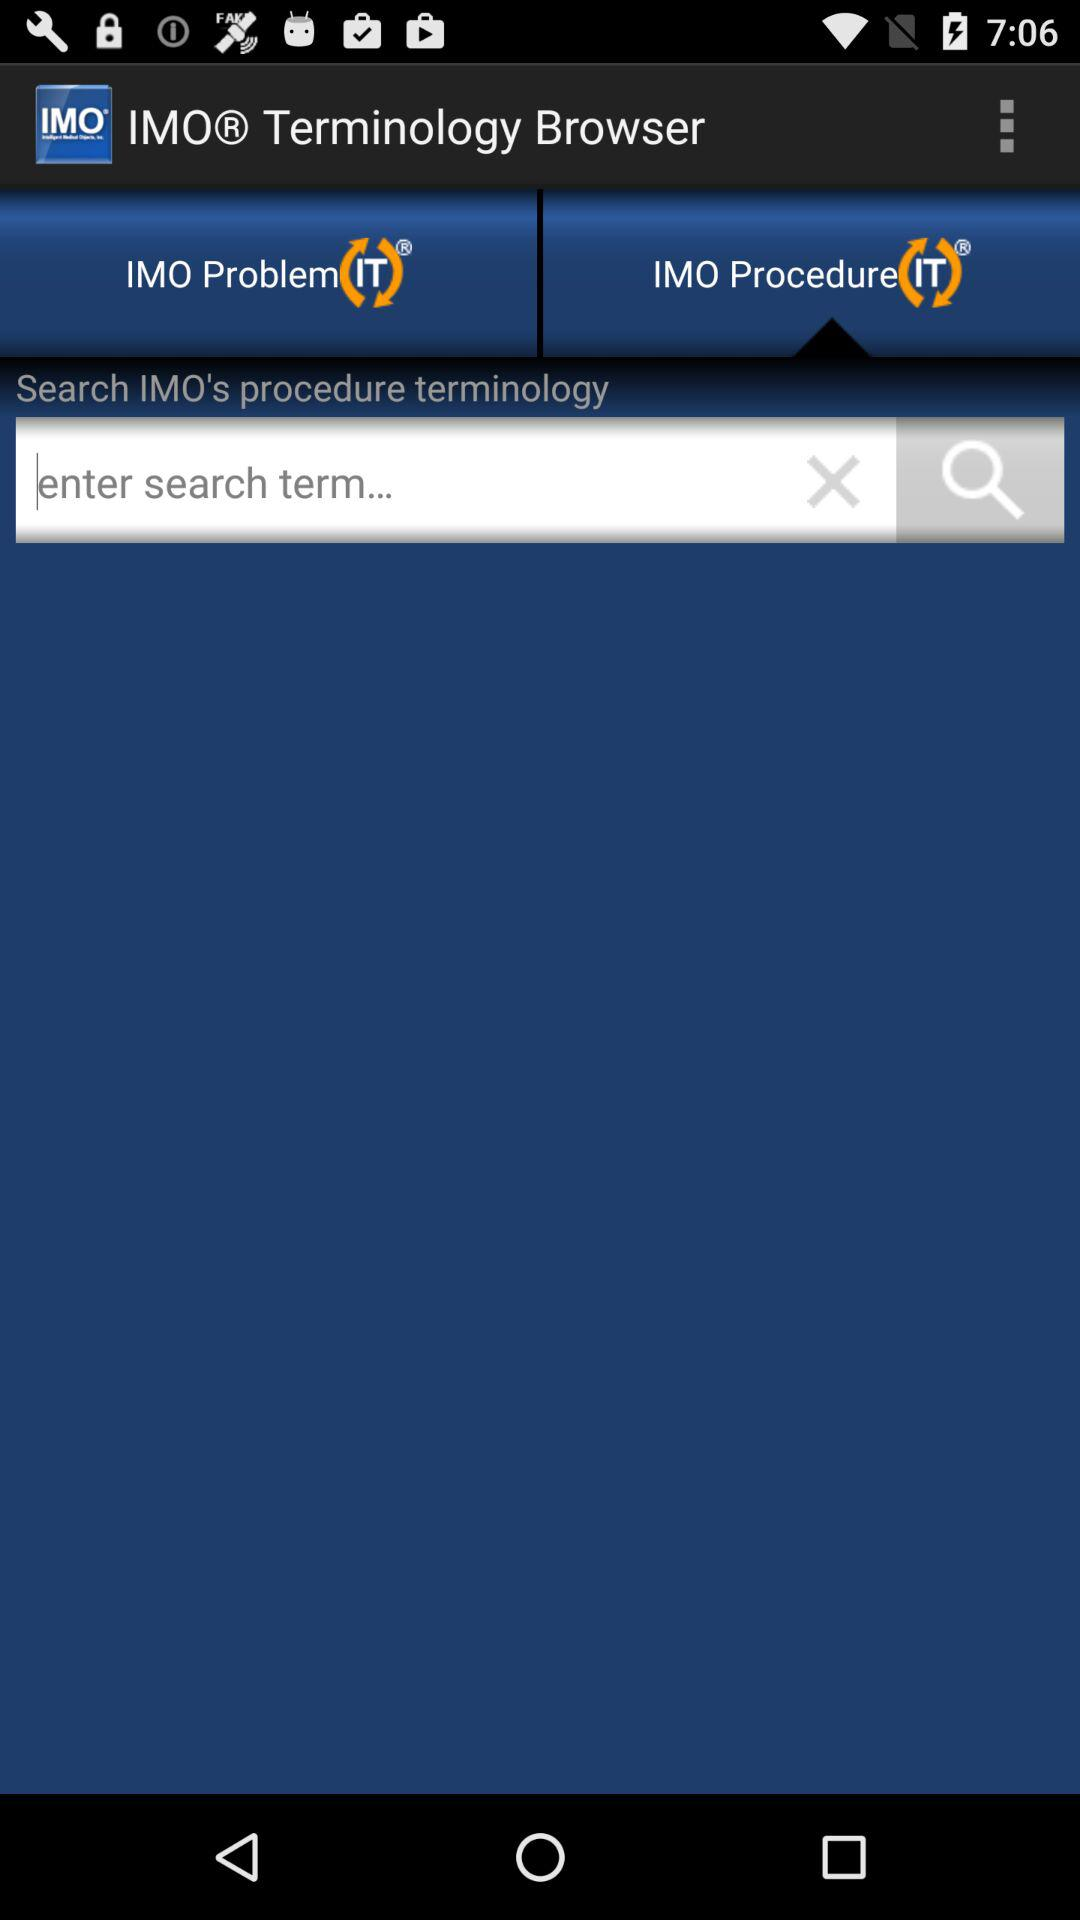What is the name of the application? The name of the application is "IMOⓇ Terminology Browser". 